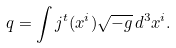Convert formula to latex. <formula><loc_0><loc_0><loc_500><loc_500>q = \int j ^ { t } ( x ^ { i } ) \sqrt { - g } \, d ^ { 3 } x ^ { i } .</formula> 